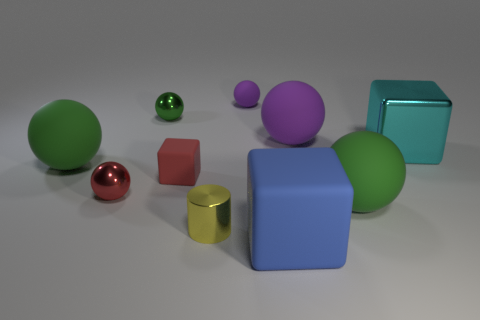Is the shape of the tiny red rubber object the same as the big green matte object in front of the tiny red matte object?
Keep it short and to the point. No. What number of green matte things have the same size as the red sphere?
Provide a short and direct response. 0. There is a green matte thing right of the tiny block; does it have the same shape as the big rubber thing behind the big cyan shiny object?
Offer a terse response. Yes. There is a tiny metal thing that is the same color as the tiny block; what is its shape?
Your answer should be compact. Sphere. There is a thing right of the green sphere on the right side of the red cube; what is its color?
Give a very brief answer. Cyan. There is a small matte thing that is the same shape as the large blue matte thing; what color is it?
Your response must be concise. Red. Is there anything else that has the same material as the blue object?
Ensure brevity in your answer.  Yes. What size is the red object that is the same shape as the cyan object?
Offer a terse response. Small. What material is the large green object to the right of the small purple rubber ball?
Keep it short and to the point. Rubber. Are there fewer big shiny blocks behind the big cyan shiny block than small green shiny things?
Your answer should be compact. Yes. 